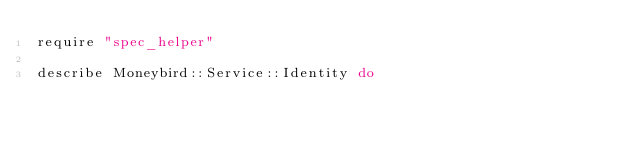Convert code to text. <code><loc_0><loc_0><loc_500><loc_500><_Ruby_>require "spec_helper"

describe Moneybird::Service::Identity do</code> 